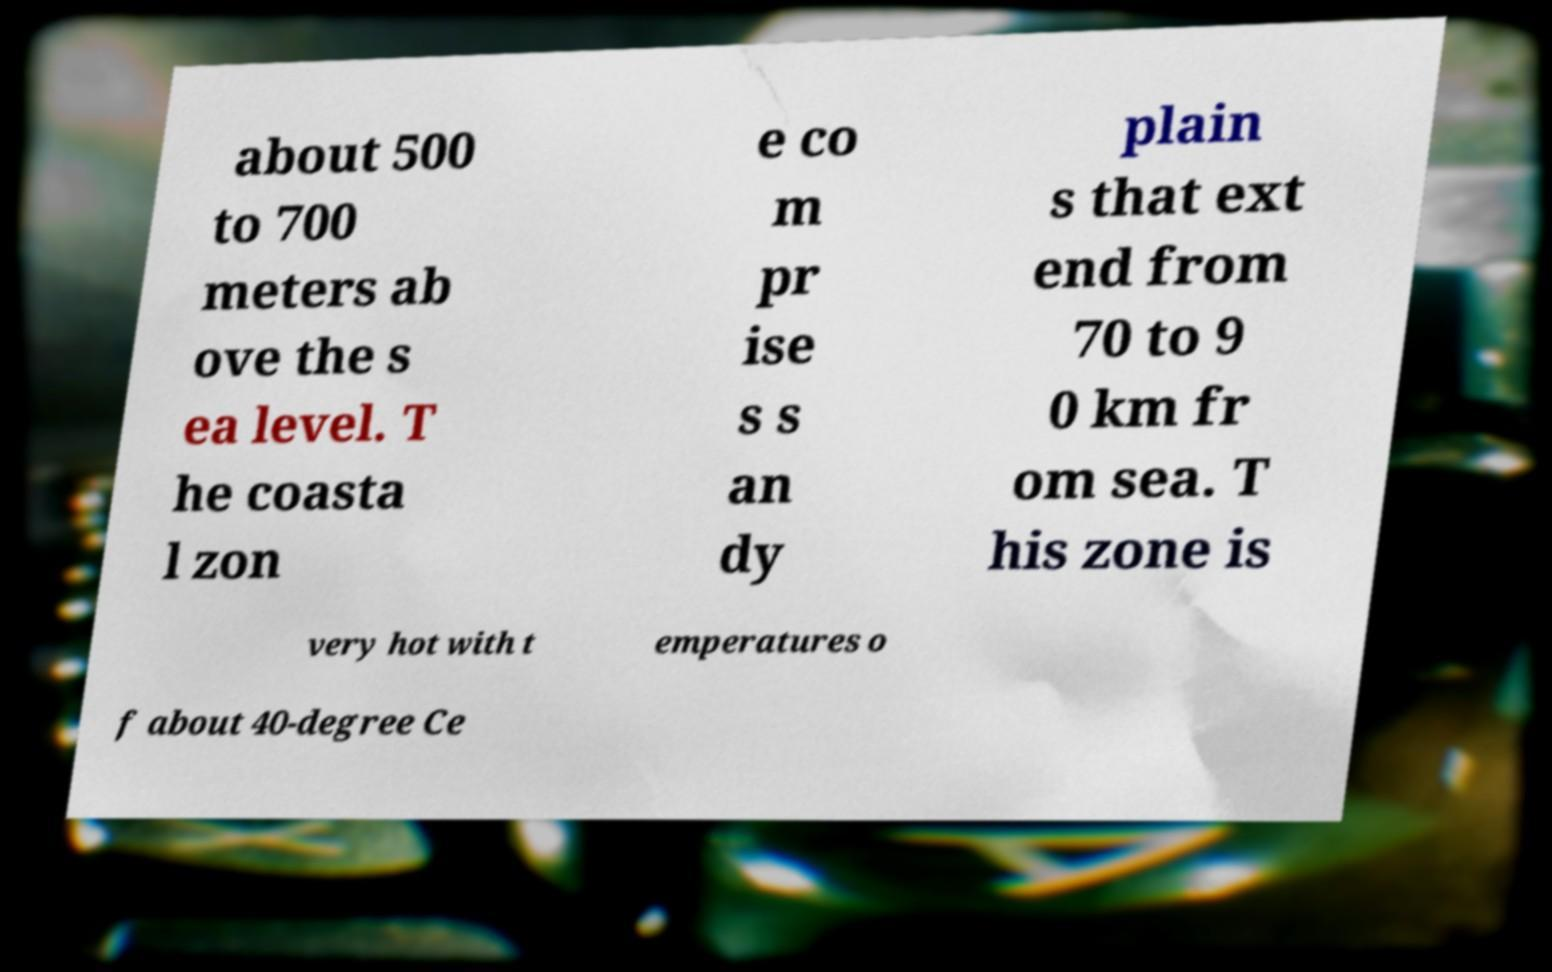Please identify and transcribe the text found in this image. about 500 to 700 meters ab ove the s ea level. T he coasta l zon e co m pr ise s s an dy plain s that ext end from 70 to 9 0 km fr om sea. T his zone is very hot with t emperatures o f about 40-degree Ce 